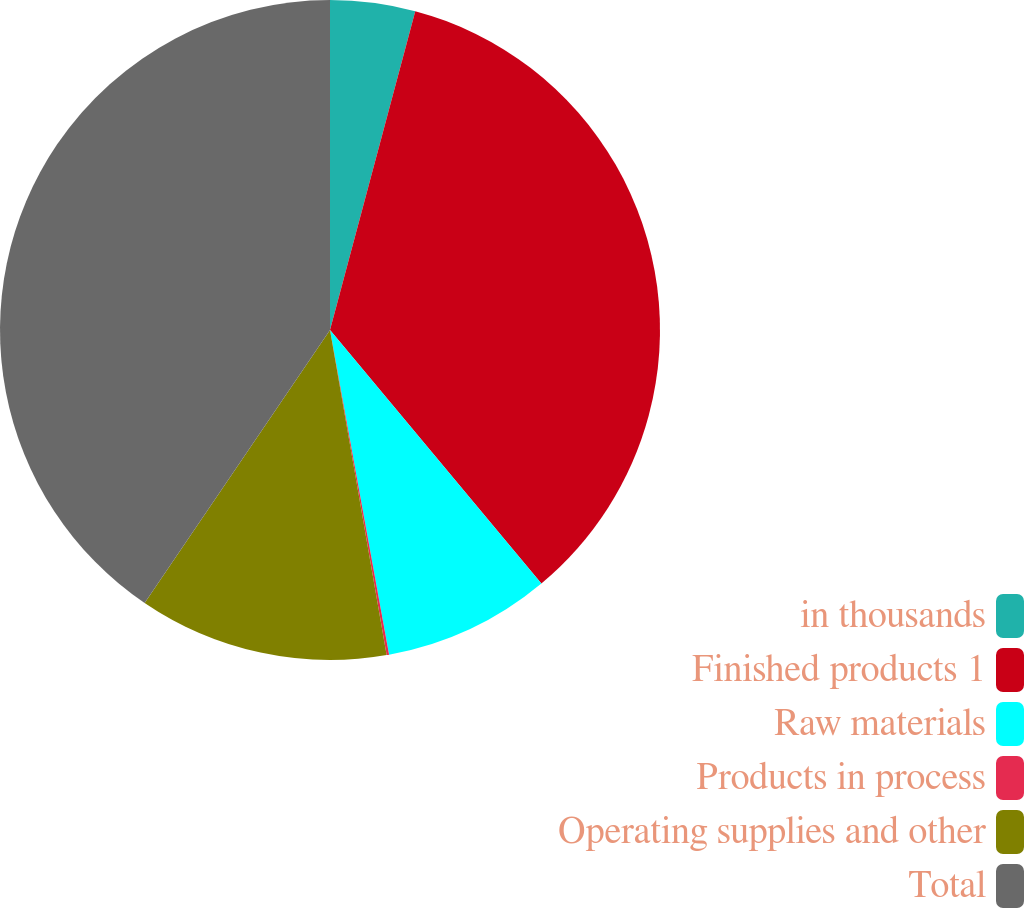<chart> <loc_0><loc_0><loc_500><loc_500><pie_chart><fcel>in thousands<fcel>Finished products 1<fcel>Raw materials<fcel>Products in process<fcel>Operating supplies and other<fcel>Total<nl><fcel>4.16%<fcel>34.78%<fcel>8.2%<fcel>0.12%<fcel>12.24%<fcel>40.51%<nl></chart> 